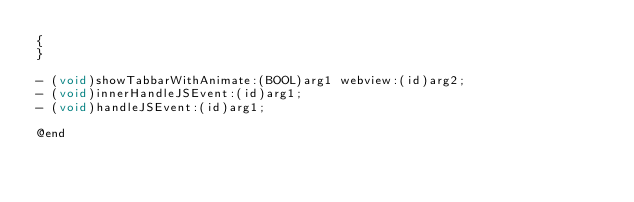<code> <loc_0><loc_0><loc_500><loc_500><_C_>{
}

- (void)showTabbarWithAnimate:(BOOL)arg1 webview:(id)arg2;
- (void)innerHandleJSEvent:(id)arg1;
- (void)handleJSEvent:(id)arg1;

@end

</code> 